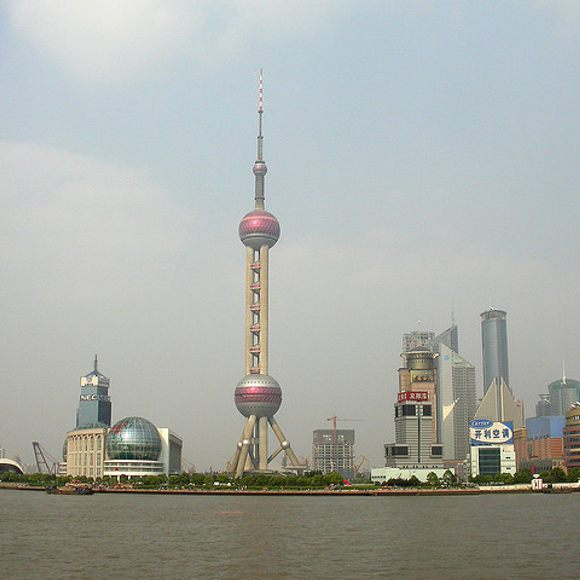Can you describe the Oriental Pearl Tower's surroundings? Sure! The Oriental Pearl Tower is surrounded by a diverse array of modern skyscrapers and buildings that exemplify Shanghai's urban architecture. To the left of the tower, you can see uniquely designed buildings with distinctive shapes and structures, while to the right, there are more traditional office skyscrapers. The area around the tower is very green with well-maintained landscaping and trees. There's a wide, open space that seems to be part of a park or promenade, offering pedestrians a scenic area to walk and admire the beauty of the city. Additionally, the body of water in the foreground creates a natural boundary, accentuating the serenity amidst the urban hustle. 